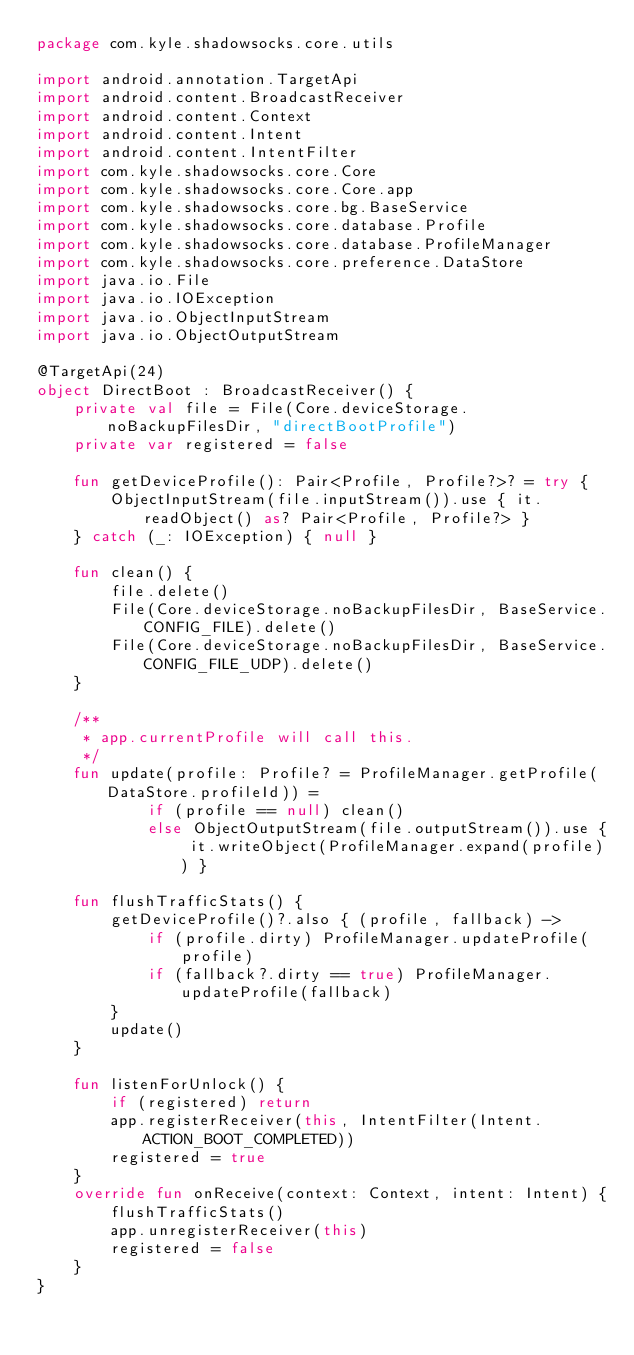<code> <loc_0><loc_0><loc_500><loc_500><_Kotlin_>package com.kyle.shadowsocks.core.utils

import android.annotation.TargetApi
import android.content.BroadcastReceiver
import android.content.Context
import android.content.Intent
import android.content.IntentFilter
import com.kyle.shadowsocks.core.Core
import com.kyle.shadowsocks.core.Core.app
import com.kyle.shadowsocks.core.bg.BaseService
import com.kyle.shadowsocks.core.database.Profile
import com.kyle.shadowsocks.core.database.ProfileManager
import com.kyle.shadowsocks.core.preference.DataStore
import java.io.File
import java.io.IOException
import java.io.ObjectInputStream
import java.io.ObjectOutputStream

@TargetApi(24)
object DirectBoot : BroadcastReceiver() {
    private val file = File(Core.deviceStorage.noBackupFilesDir, "directBootProfile")
    private var registered = false

    fun getDeviceProfile(): Pair<Profile, Profile?>? = try {
        ObjectInputStream(file.inputStream()).use { it.readObject() as? Pair<Profile, Profile?> }
    } catch (_: IOException) { null }

    fun clean() {
        file.delete()
        File(Core.deviceStorage.noBackupFilesDir, BaseService.CONFIG_FILE).delete()
        File(Core.deviceStorage.noBackupFilesDir, BaseService.CONFIG_FILE_UDP).delete()
    }

    /**
     * app.currentProfile will call this.
     */
    fun update(profile: Profile? = ProfileManager.getProfile(DataStore.profileId)) =
            if (profile == null) clean()
            else ObjectOutputStream(file.outputStream()).use { it.writeObject(ProfileManager.expand(profile)) }

    fun flushTrafficStats() {
        getDeviceProfile()?.also { (profile, fallback) ->
            if (profile.dirty) ProfileManager.updateProfile(profile)
            if (fallback?.dirty == true) ProfileManager.updateProfile(fallback)
        }
        update()
    }

    fun listenForUnlock() {
        if (registered) return
        app.registerReceiver(this, IntentFilter(Intent.ACTION_BOOT_COMPLETED))
        registered = true
    }
    override fun onReceive(context: Context, intent: Intent) {
        flushTrafficStats()
        app.unregisterReceiver(this)
        registered = false
    }
}
</code> 